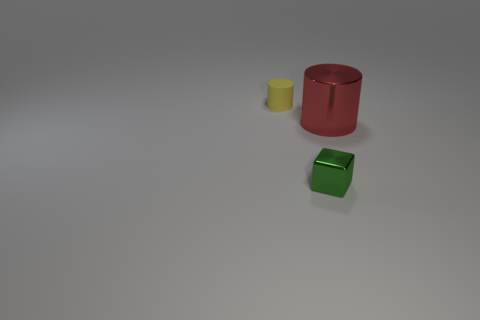How many cylinders are large cyan rubber objects or yellow matte objects?
Ensure brevity in your answer.  1. The red object that is the same shape as the yellow matte object is what size?
Provide a succinct answer. Large. What number of rubber objects are there?
Make the answer very short. 1. Does the green thing have the same shape as the small thing behind the big thing?
Make the answer very short. No. How big is the object on the left side of the green shiny object?
Give a very brief answer. Small. What is the material of the green object?
Make the answer very short. Metal. Is the shape of the object that is on the left side of the shiny block the same as  the big red object?
Your response must be concise. Yes. Are there any blocks of the same size as the red metal cylinder?
Your answer should be very brief. No. Are there any green metallic cubes that are behind the cylinder that is in front of the cylinder that is on the left side of the green shiny cube?
Keep it short and to the point. No. There is a tiny matte cylinder; is it the same color as the shiny object right of the small shiny block?
Provide a short and direct response. No. 